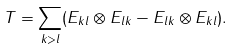<formula> <loc_0><loc_0><loc_500><loc_500>T = \sum _ { k > l } ( E _ { k l } \otimes E _ { l k } - E _ { l k } \otimes E _ { k l } ) .</formula> 